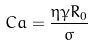Convert formula to latex. <formula><loc_0><loc_0><loc_500><loc_500>C a = \frac { \eta \dot { \gamma } R _ { 0 } } { \sigma }</formula> 